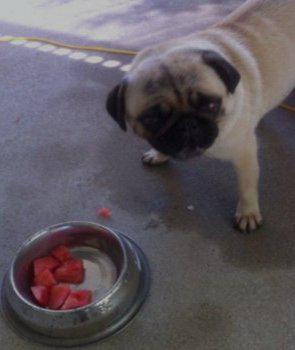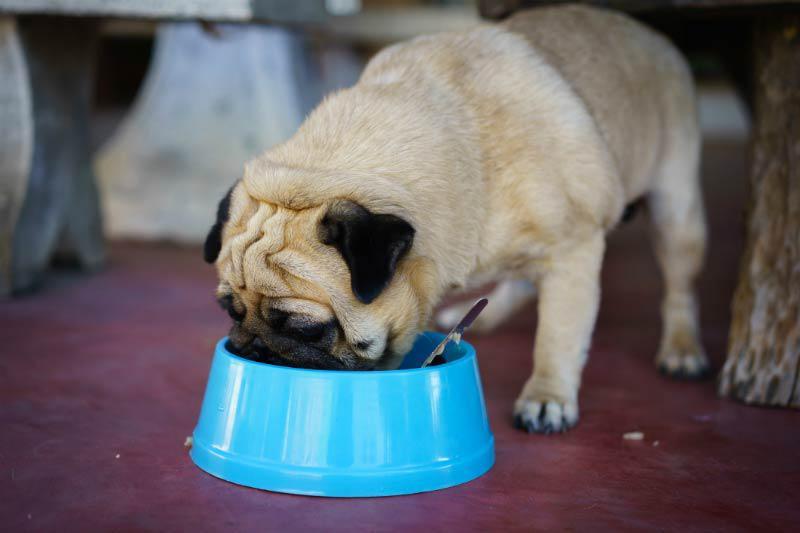The first image is the image on the left, the second image is the image on the right. For the images displayed, is the sentence "In one of the images there is one dog and one round silver dog food dish." factually correct? Answer yes or no. Yes. The first image is the image on the left, the second image is the image on the right. For the images shown, is this caption "One dog is standing with his face bent down in a bowl, and the other dog is looking at the camera." true? Answer yes or no. Yes. 